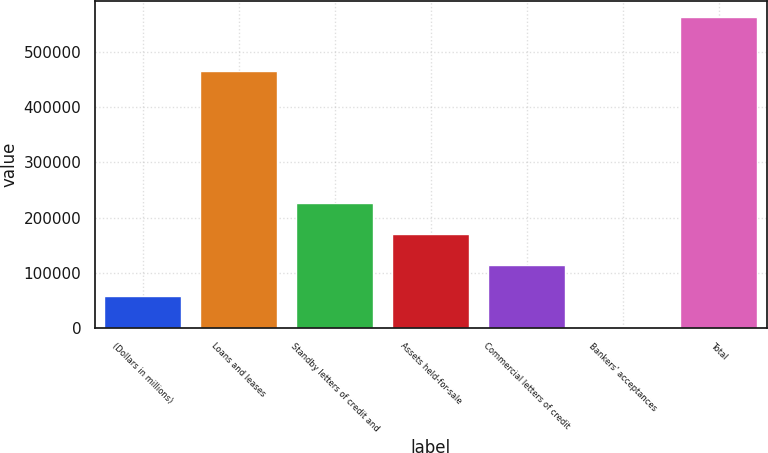Convert chart to OTSL. <chart><loc_0><loc_0><loc_500><loc_500><bar_chart><fcel>(Dollars in millions)<fcel>Loans and leases<fcel>Standby letters of credit and<fcel>Assets held-for-sale<fcel>Commercial letters of credit<fcel>Bankers' acceptances<fcel>Total<nl><fcel>57887.6<fcel>464963<fcel>226618<fcel>170375<fcel>114131<fcel>1644<fcel>564080<nl></chart> 